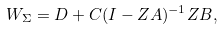Convert formula to latex. <formula><loc_0><loc_0><loc_500><loc_500>W _ { \Sigma } = D + C ( I - Z A ) ^ { - 1 } Z B ,</formula> 